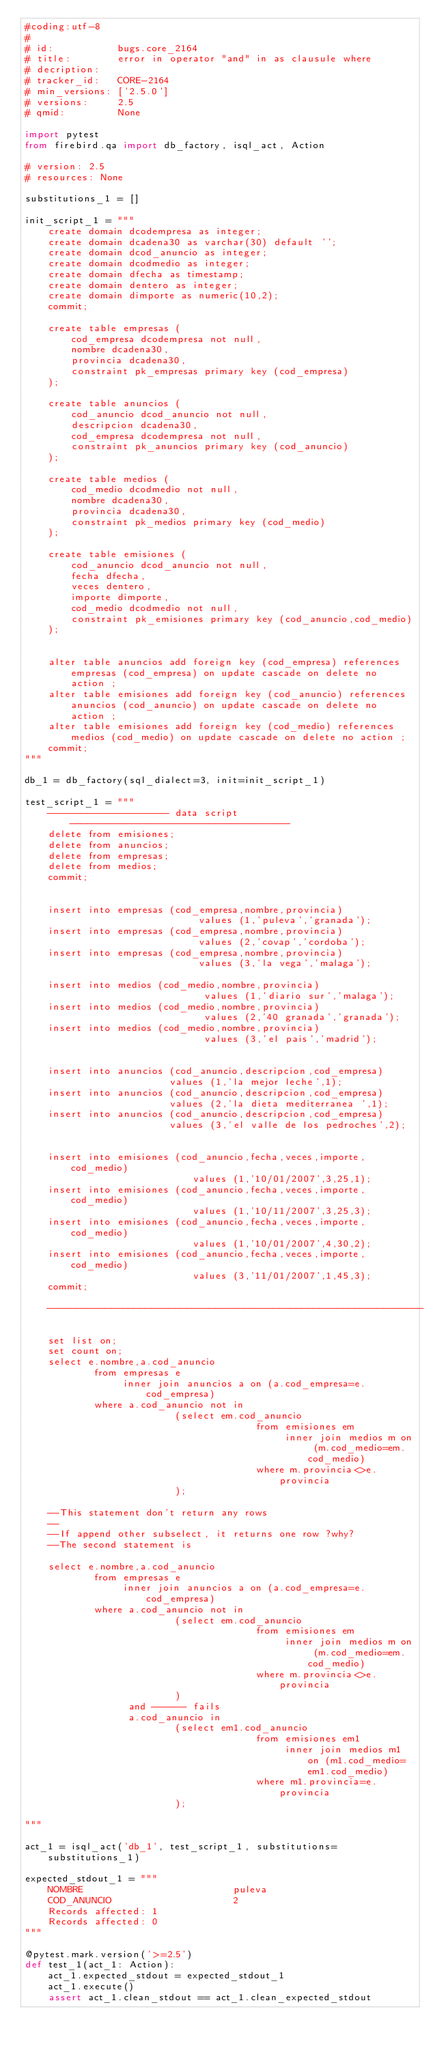Convert code to text. <code><loc_0><loc_0><loc_500><loc_500><_Python_>#coding:utf-8
#
# id:           bugs.core_2164
# title:        error in operator "and" in as clausule where
# decription:   
# tracker_id:   CORE-2164
# min_versions: ['2.5.0']
# versions:     2.5
# qmid:         None

import pytest
from firebird.qa import db_factory, isql_act, Action

# version: 2.5
# resources: None

substitutions_1 = []

init_script_1 = """
    create domain dcodempresa as integer;
    create domain dcadena30 as varchar(30) default '';
    create domain dcod_anuncio as integer;
    create domain dcodmedio as integer;
    create domain dfecha as timestamp;
    create domain dentero as integer;
    create domain dimporte as numeric(10,2);
    commit;

    create table empresas (
        cod_empresa dcodempresa not null,
        nombre dcadena30,
        provincia dcadena30,
        constraint pk_empresas primary key (cod_empresa)
    );

    create table anuncios (
        cod_anuncio dcod_anuncio not null,
        descripcion dcadena30,
        cod_empresa dcodempresa not null,
        constraint pk_anuncios primary key (cod_anuncio)
    );

    create table medios (
        cod_medio dcodmedio not null,
        nombre dcadena30,
        provincia dcadena30,
        constraint pk_medios primary key (cod_medio)
    );

    create table emisiones (
        cod_anuncio dcod_anuncio not null,
        fecha dfecha,
        veces dentero,
        importe dimporte,
        cod_medio dcodmedio not null,
        constraint pk_emisiones primary key (cod_anuncio,cod_medio)
    );


    alter table anuncios add foreign key (cod_empresa) references empresas (cod_empresa) on update cascade on delete no action ;
    alter table emisiones add foreign key (cod_anuncio) references anuncios (cod_anuncio) on update cascade on delete no action ;
    alter table emisiones add foreign key (cod_medio) references medios (cod_medio) on update cascade on delete no action ;
    commit;
"""

db_1 = db_factory(sql_dialect=3, init=init_script_1)

test_script_1 = """
    --------------------- data script --------------------------------------
    delete from emisiones;
    delete from anuncios;
    delete from empresas;
    delete from medios;
    commit;


    insert into empresas (cod_empresa,nombre,provincia)
                              values (1,'puleva','granada');
    insert into empresas (cod_empresa,nombre,provincia)
                              values (2,'covap','cordoba');
    insert into empresas (cod_empresa,nombre,provincia)
                              values (3,'la vega','malaga');

    insert into medios (cod_medio,nombre,provincia)
                               values (1,'diario sur','malaga');
    insert into medios (cod_medio,nombre,provincia)
                               values (2,'40 granada','granada');
    insert into medios (cod_medio,nombre,provincia)
                               values (3,'el pais','madrid');


    insert into anuncios (cod_anuncio,descripcion,cod_empresa)
                         values (1,'la mejor leche',1);
    insert into anuncios (cod_anuncio,descripcion,cod_empresa)
                         values (2,'la dieta mediterranea ',1);
    insert into anuncios (cod_anuncio,descripcion,cod_empresa)
                         values (3,'el valle de los pedroches',2);


    insert into emisiones (cod_anuncio,fecha,veces,importe,cod_medio)
                             values (1,'10/01/2007',3,25,1);
    insert into emisiones (cod_anuncio,fecha,veces,importe,cod_medio)
                             values (1,'10/11/2007',3,25,3);
    insert into emisiones (cod_anuncio,fecha,veces,importe,cod_medio)
                             values (1,'10/01/2007',4,30,2);
    insert into emisiones (cod_anuncio,fecha,veces,importe,cod_medio)
                             values (3,'11/01/2007',1,45,3);
    commit;

    -----------------------------------------------------------------

    set list on;
    set count on;
    select e.nombre,a.cod_anuncio
            from empresas e
                 inner join anuncios a on (a.cod_empresa=e.cod_empresa)
            where a.cod_anuncio not in
                          (select em.cod_anuncio
                                        from emisiones em
                                             inner join medios m on (m.cod_medio=em.cod_medio)
                                        where m.provincia<>e.provincia
                          );

    --This statement don't return any rows
    --
    --If append other subselect, it returns one row ?why?
    --The second statement is

    select e.nombre,a.cod_anuncio
            from empresas e
                 inner join anuncios a on (a.cod_empresa=e.cod_empresa)
            where a.cod_anuncio not in
                          (select em.cod_anuncio
                                        from emisiones em
                                             inner join medios m on (m.cod_medio=em.cod_medio)
                                        where m.provincia<>e.provincia
                          )
                  and ------ fails
                  a.cod_anuncio in
                          (select em1.cod_anuncio
                                        from emisiones em1
                                             inner join medios m1 on (m1.cod_medio=em1.cod_medio)
                                        where m1.provincia=e.provincia
                          );

"""

act_1 = isql_act('db_1', test_script_1, substitutions=substitutions_1)

expected_stdout_1 = """
    NOMBRE                          puleva
    COD_ANUNCIO                     2
    Records affected: 1
    Records affected: 0
"""

@pytest.mark.version('>=2.5')
def test_1(act_1: Action):
    act_1.expected_stdout = expected_stdout_1
    act_1.execute()
    assert act_1.clean_stdout == act_1.clean_expected_stdout

</code> 